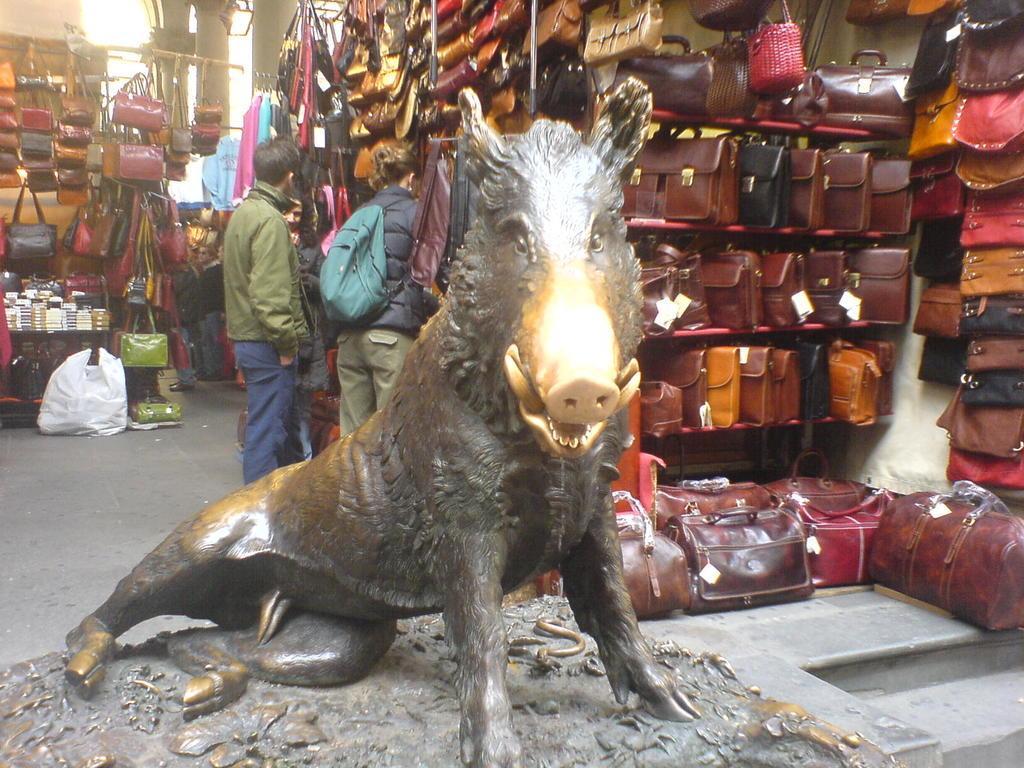Describe this image in one or two sentences. In this picture at front there is a statue of an animal and at the background there are bags placed on the rack and at the backside of the statue there are three people standing. 